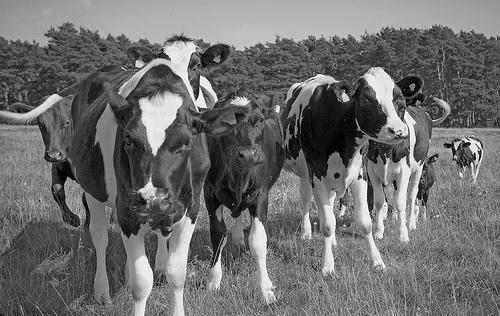How many tags does each cow have?
Give a very brief answer. 2. 